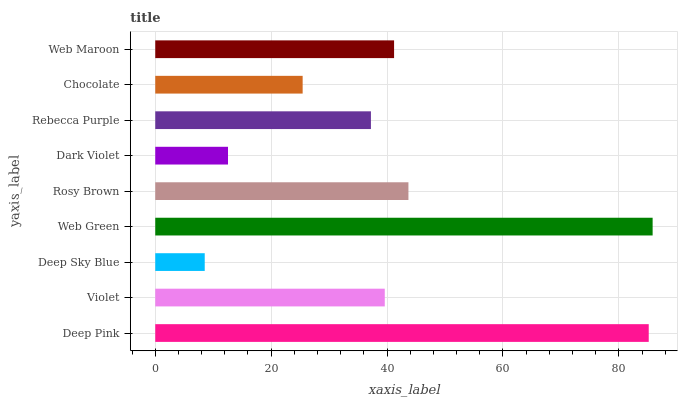Is Deep Sky Blue the minimum?
Answer yes or no. Yes. Is Web Green the maximum?
Answer yes or no. Yes. Is Violet the minimum?
Answer yes or no. No. Is Violet the maximum?
Answer yes or no. No. Is Deep Pink greater than Violet?
Answer yes or no. Yes. Is Violet less than Deep Pink?
Answer yes or no. Yes. Is Violet greater than Deep Pink?
Answer yes or no. No. Is Deep Pink less than Violet?
Answer yes or no. No. Is Violet the high median?
Answer yes or no. Yes. Is Violet the low median?
Answer yes or no. Yes. Is Chocolate the high median?
Answer yes or no. No. Is Web Maroon the low median?
Answer yes or no. No. 